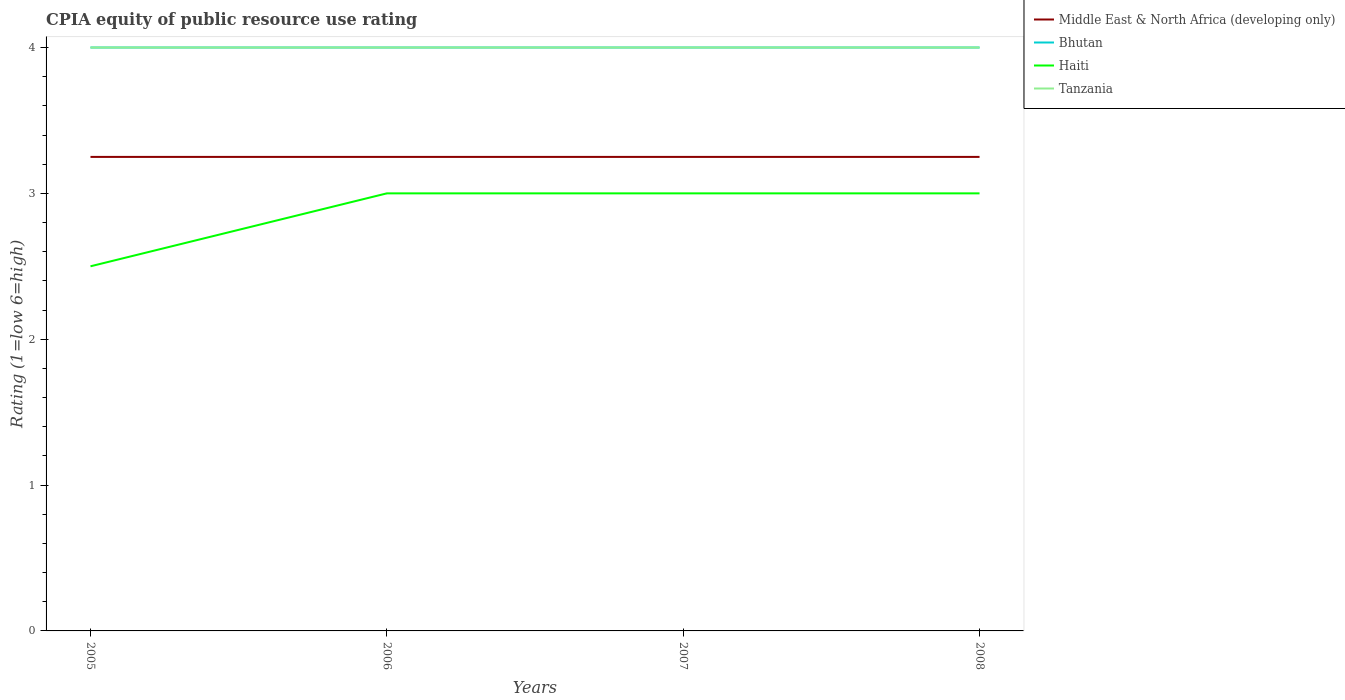How many different coloured lines are there?
Make the answer very short. 4. Across all years, what is the maximum CPIA rating in Tanzania?
Ensure brevity in your answer.  4. In which year was the CPIA rating in Middle East & North Africa (developing only) maximum?
Give a very brief answer. 2005. What is the total CPIA rating in Middle East & North Africa (developing only) in the graph?
Your response must be concise. 0. What is the difference between the highest and the lowest CPIA rating in Haiti?
Offer a very short reply. 3. How many lines are there?
Your answer should be very brief. 4. How many years are there in the graph?
Your response must be concise. 4. What is the difference between two consecutive major ticks on the Y-axis?
Offer a very short reply. 1. Are the values on the major ticks of Y-axis written in scientific E-notation?
Provide a succinct answer. No. Does the graph contain grids?
Ensure brevity in your answer.  No. How are the legend labels stacked?
Provide a short and direct response. Vertical. What is the title of the graph?
Your answer should be compact. CPIA equity of public resource use rating. What is the label or title of the Y-axis?
Ensure brevity in your answer.  Rating (1=low 6=high). What is the Rating (1=low 6=high) in Middle East & North Africa (developing only) in 2005?
Ensure brevity in your answer.  3.25. What is the Rating (1=low 6=high) in Bhutan in 2005?
Offer a very short reply. 4. What is the Rating (1=low 6=high) of Tanzania in 2005?
Provide a short and direct response. 4. What is the Rating (1=low 6=high) in Middle East & North Africa (developing only) in 2006?
Keep it short and to the point. 3.25. What is the Rating (1=low 6=high) in Bhutan in 2006?
Your response must be concise. 4. What is the Rating (1=low 6=high) of Tanzania in 2006?
Your answer should be compact. 4. What is the Rating (1=low 6=high) of Middle East & North Africa (developing only) in 2007?
Provide a succinct answer. 3.25. What is the Rating (1=low 6=high) of Bhutan in 2007?
Provide a short and direct response. 4. What is the Rating (1=low 6=high) in Middle East & North Africa (developing only) in 2008?
Give a very brief answer. 3.25. What is the Rating (1=low 6=high) of Haiti in 2008?
Your response must be concise. 3. Across all years, what is the maximum Rating (1=low 6=high) in Bhutan?
Keep it short and to the point. 4. Across all years, what is the maximum Rating (1=low 6=high) of Tanzania?
Provide a short and direct response. 4. Across all years, what is the minimum Rating (1=low 6=high) of Haiti?
Your answer should be compact. 2.5. Across all years, what is the minimum Rating (1=low 6=high) of Tanzania?
Your answer should be very brief. 4. What is the total Rating (1=low 6=high) in Bhutan in the graph?
Your answer should be compact. 16. What is the total Rating (1=low 6=high) in Haiti in the graph?
Provide a short and direct response. 11.5. What is the difference between the Rating (1=low 6=high) in Bhutan in 2005 and that in 2006?
Provide a succinct answer. 0. What is the difference between the Rating (1=low 6=high) of Tanzania in 2005 and that in 2006?
Keep it short and to the point. 0. What is the difference between the Rating (1=low 6=high) in Haiti in 2005 and that in 2007?
Your answer should be very brief. -0.5. What is the difference between the Rating (1=low 6=high) of Tanzania in 2005 and that in 2007?
Provide a short and direct response. 0. What is the difference between the Rating (1=low 6=high) of Bhutan in 2005 and that in 2008?
Give a very brief answer. 0. What is the difference between the Rating (1=low 6=high) in Haiti in 2005 and that in 2008?
Offer a terse response. -0.5. What is the difference between the Rating (1=low 6=high) in Tanzania in 2005 and that in 2008?
Keep it short and to the point. 0. What is the difference between the Rating (1=low 6=high) of Tanzania in 2006 and that in 2007?
Keep it short and to the point. 0. What is the difference between the Rating (1=low 6=high) in Middle East & North Africa (developing only) in 2006 and that in 2008?
Provide a short and direct response. 0. What is the difference between the Rating (1=low 6=high) of Bhutan in 2006 and that in 2008?
Provide a short and direct response. 0. What is the difference between the Rating (1=low 6=high) in Haiti in 2006 and that in 2008?
Keep it short and to the point. 0. What is the difference between the Rating (1=low 6=high) of Tanzania in 2006 and that in 2008?
Your answer should be very brief. 0. What is the difference between the Rating (1=low 6=high) of Middle East & North Africa (developing only) in 2007 and that in 2008?
Ensure brevity in your answer.  0. What is the difference between the Rating (1=low 6=high) in Bhutan in 2007 and that in 2008?
Your response must be concise. 0. What is the difference between the Rating (1=low 6=high) of Haiti in 2007 and that in 2008?
Your answer should be compact. 0. What is the difference between the Rating (1=low 6=high) in Tanzania in 2007 and that in 2008?
Ensure brevity in your answer.  0. What is the difference between the Rating (1=low 6=high) in Middle East & North Africa (developing only) in 2005 and the Rating (1=low 6=high) in Bhutan in 2006?
Provide a succinct answer. -0.75. What is the difference between the Rating (1=low 6=high) in Middle East & North Africa (developing only) in 2005 and the Rating (1=low 6=high) in Tanzania in 2006?
Your answer should be compact. -0.75. What is the difference between the Rating (1=low 6=high) in Middle East & North Africa (developing only) in 2005 and the Rating (1=low 6=high) in Bhutan in 2007?
Offer a terse response. -0.75. What is the difference between the Rating (1=low 6=high) in Middle East & North Africa (developing only) in 2005 and the Rating (1=low 6=high) in Haiti in 2007?
Your response must be concise. 0.25. What is the difference between the Rating (1=low 6=high) in Middle East & North Africa (developing only) in 2005 and the Rating (1=low 6=high) in Tanzania in 2007?
Offer a terse response. -0.75. What is the difference between the Rating (1=low 6=high) in Bhutan in 2005 and the Rating (1=low 6=high) in Haiti in 2007?
Offer a terse response. 1. What is the difference between the Rating (1=low 6=high) in Haiti in 2005 and the Rating (1=low 6=high) in Tanzania in 2007?
Offer a very short reply. -1.5. What is the difference between the Rating (1=low 6=high) in Middle East & North Africa (developing only) in 2005 and the Rating (1=low 6=high) in Bhutan in 2008?
Offer a very short reply. -0.75. What is the difference between the Rating (1=low 6=high) in Middle East & North Africa (developing only) in 2005 and the Rating (1=low 6=high) in Tanzania in 2008?
Keep it short and to the point. -0.75. What is the difference between the Rating (1=low 6=high) in Bhutan in 2005 and the Rating (1=low 6=high) in Haiti in 2008?
Your answer should be compact. 1. What is the difference between the Rating (1=low 6=high) in Middle East & North Africa (developing only) in 2006 and the Rating (1=low 6=high) in Bhutan in 2007?
Make the answer very short. -0.75. What is the difference between the Rating (1=low 6=high) of Middle East & North Africa (developing only) in 2006 and the Rating (1=low 6=high) of Haiti in 2007?
Your answer should be very brief. 0.25. What is the difference between the Rating (1=low 6=high) of Middle East & North Africa (developing only) in 2006 and the Rating (1=low 6=high) of Tanzania in 2007?
Give a very brief answer. -0.75. What is the difference between the Rating (1=low 6=high) in Middle East & North Africa (developing only) in 2006 and the Rating (1=low 6=high) in Bhutan in 2008?
Ensure brevity in your answer.  -0.75. What is the difference between the Rating (1=low 6=high) of Middle East & North Africa (developing only) in 2006 and the Rating (1=low 6=high) of Tanzania in 2008?
Offer a very short reply. -0.75. What is the difference between the Rating (1=low 6=high) in Bhutan in 2006 and the Rating (1=low 6=high) in Haiti in 2008?
Give a very brief answer. 1. What is the difference between the Rating (1=low 6=high) of Haiti in 2006 and the Rating (1=low 6=high) of Tanzania in 2008?
Your answer should be very brief. -1. What is the difference between the Rating (1=low 6=high) in Middle East & North Africa (developing only) in 2007 and the Rating (1=low 6=high) in Bhutan in 2008?
Give a very brief answer. -0.75. What is the difference between the Rating (1=low 6=high) of Middle East & North Africa (developing only) in 2007 and the Rating (1=low 6=high) of Haiti in 2008?
Your answer should be very brief. 0.25. What is the difference between the Rating (1=low 6=high) of Middle East & North Africa (developing only) in 2007 and the Rating (1=low 6=high) of Tanzania in 2008?
Offer a terse response. -0.75. What is the difference between the Rating (1=low 6=high) in Bhutan in 2007 and the Rating (1=low 6=high) in Haiti in 2008?
Make the answer very short. 1. What is the difference between the Rating (1=low 6=high) of Haiti in 2007 and the Rating (1=low 6=high) of Tanzania in 2008?
Ensure brevity in your answer.  -1. What is the average Rating (1=low 6=high) in Haiti per year?
Offer a very short reply. 2.88. In the year 2005, what is the difference between the Rating (1=low 6=high) in Middle East & North Africa (developing only) and Rating (1=low 6=high) in Bhutan?
Keep it short and to the point. -0.75. In the year 2005, what is the difference between the Rating (1=low 6=high) of Middle East & North Africa (developing only) and Rating (1=low 6=high) of Tanzania?
Keep it short and to the point. -0.75. In the year 2006, what is the difference between the Rating (1=low 6=high) of Middle East & North Africa (developing only) and Rating (1=low 6=high) of Bhutan?
Your answer should be compact. -0.75. In the year 2006, what is the difference between the Rating (1=low 6=high) of Middle East & North Africa (developing only) and Rating (1=low 6=high) of Haiti?
Your answer should be very brief. 0.25. In the year 2006, what is the difference between the Rating (1=low 6=high) in Middle East & North Africa (developing only) and Rating (1=low 6=high) in Tanzania?
Offer a very short reply. -0.75. In the year 2006, what is the difference between the Rating (1=low 6=high) in Bhutan and Rating (1=low 6=high) in Haiti?
Make the answer very short. 1. In the year 2006, what is the difference between the Rating (1=low 6=high) of Haiti and Rating (1=low 6=high) of Tanzania?
Provide a succinct answer. -1. In the year 2007, what is the difference between the Rating (1=low 6=high) of Middle East & North Africa (developing only) and Rating (1=low 6=high) of Bhutan?
Your answer should be very brief. -0.75. In the year 2007, what is the difference between the Rating (1=low 6=high) in Middle East & North Africa (developing only) and Rating (1=low 6=high) in Haiti?
Your answer should be compact. 0.25. In the year 2007, what is the difference between the Rating (1=low 6=high) in Middle East & North Africa (developing only) and Rating (1=low 6=high) in Tanzania?
Your answer should be very brief. -0.75. In the year 2007, what is the difference between the Rating (1=low 6=high) of Bhutan and Rating (1=low 6=high) of Haiti?
Make the answer very short. 1. In the year 2007, what is the difference between the Rating (1=low 6=high) in Bhutan and Rating (1=low 6=high) in Tanzania?
Make the answer very short. 0. In the year 2008, what is the difference between the Rating (1=low 6=high) of Middle East & North Africa (developing only) and Rating (1=low 6=high) of Bhutan?
Keep it short and to the point. -0.75. In the year 2008, what is the difference between the Rating (1=low 6=high) of Middle East & North Africa (developing only) and Rating (1=low 6=high) of Haiti?
Keep it short and to the point. 0.25. In the year 2008, what is the difference between the Rating (1=low 6=high) of Middle East & North Africa (developing only) and Rating (1=low 6=high) of Tanzania?
Ensure brevity in your answer.  -0.75. In the year 2008, what is the difference between the Rating (1=low 6=high) of Bhutan and Rating (1=low 6=high) of Haiti?
Offer a very short reply. 1. In the year 2008, what is the difference between the Rating (1=low 6=high) of Bhutan and Rating (1=low 6=high) of Tanzania?
Your answer should be compact. 0. In the year 2008, what is the difference between the Rating (1=low 6=high) of Haiti and Rating (1=low 6=high) of Tanzania?
Make the answer very short. -1. What is the ratio of the Rating (1=low 6=high) of Middle East & North Africa (developing only) in 2005 to that in 2006?
Keep it short and to the point. 1. What is the ratio of the Rating (1=low 6=high) in Haiti in 2005 to that in 2006?
Your answer should be very brief. 0.83. What is the ratio of the Rating (1=low 6=high) in Bhutan in 2005 to that in 2007?
Your answer should be compact. 1. What is the ratio of the Rating (1=low 6=high) of Bhutan in 2005 to that in 2008?
Your answer should be very brief. 1. What is the ratio of the Rating (1=low 6=high) in Tanzania in 2005 to that in 2008?
Ensure brevity in your answer.  1. What is the ratio of the Rating (1=low 6=high) of Middle East & North Africa (developing only) in 2006 to that in 2007?
Offer a terse response. 1. What is the ratio of the Rating (1=low 6=high) of Bhutan in 2006 to that in 2007?
Your answer should be compact. 1. What is the ratio of the Rating (1=low 6=high) in Haiti in 2006 to that in 2007?
Your response must be concise. 1. What is the ratio of the Rating (1=low 6=high) of Tanzania in 2006 to that in 2007?
Your answer should be compact. 1. What is the ratio of the Rating (1=low 6=high) in Middle East & North Africa (developing only) in 2006 to that in 2008?
Give a very brief answer. 1. What is the ratio of the Rating (1=low 6=high) in Middle East & North Africa (developing only) in 2007 to that in 2008?
Offer a very short reply. 1. What is the ratio of the Rating (1=low 6=high) of Haiti in 2007 to that in 2008?
Give a very brief answer. 1. What is the difference between the highest and the second highest Rating (1=low 6=high) in Middle East & North Africa (developing only)?
Your response must be concise. 0. What is the difference between the highest and the second highest Rating (1=low 6=high) in Bhutan?
Your answer should be very brief. 0. What is the difference between the highest and the second highest Rating (1=low 6=high) in Haiti?
Keep it short and to the point. 0. What is the difference between the highest and the second highest Rating (1=low 6=high) of Tanzania?
Give a very brief answer. 0. What is the difference between the highest and the lowest Rating (1=low 6=high) of Middle East & North Africa (developing only)?
Offer a very short reply. 0. What is the difference between the highest and the lowest Rating (1=low 6=high) in Bhutan?
Keep it short and to the point. 0. 